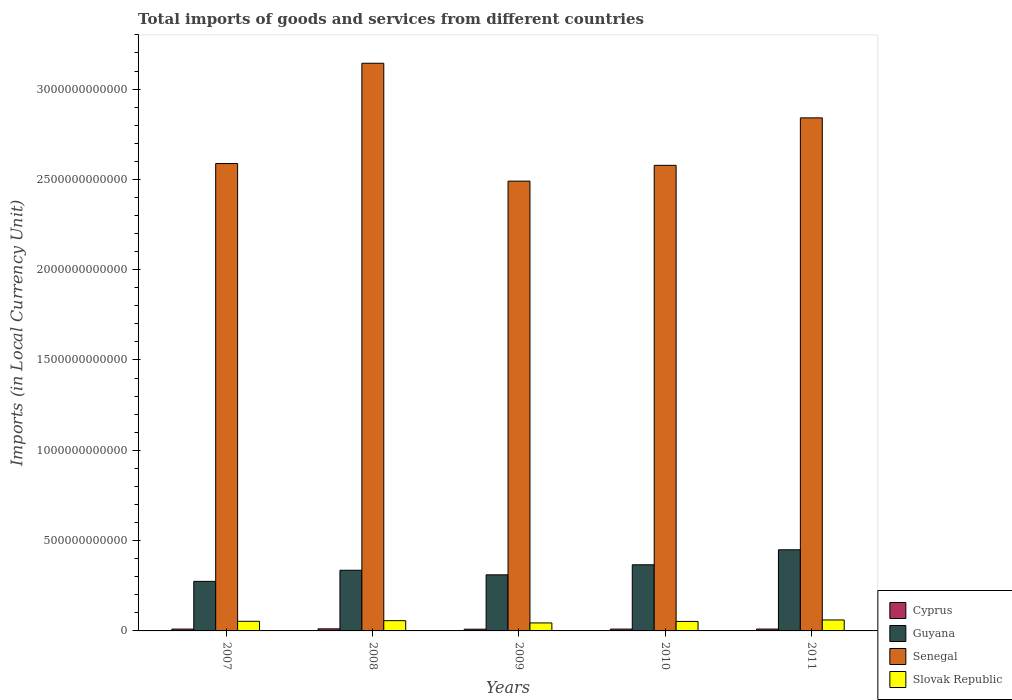How many different coloured bars are there?
Your response must be concise. 4. Are the number of bars on each tick of the X-axis equal?
Provide a succinct answer. Yes. What is the Amount of goods and services imports in Slovak Republic in 2009?
Make the answer very short. 4.42e+1. Across all years, what is the maximum Amount of goods and services imports in Guyana?
Give a very brief answer. 4.49e+11. Across all years, what is the minimum Amount of goods and services imports in Guyana?
Offer a terse response. 2.74e+11. What is the total Amount of goods and services imports in Senegal in the graph?
Your answer should be compact. 1.36e+13. What is the difference between the Amount of goods and services imports in Slovak Republic in 2008 and that in 2011?
Offer a very short reply. -3.95e+09. What is the difference between the Amount of goods and services imports in Guyana in 2011 and the Amount of goods and services imports in Cyprus in 2008?
Offer a terse response. 4.38e+11. What is the average Amount of goods and services imports in Slovak Republic per year?
Provide a short and direct response. 5.35e+1. In the year 2007, what is the difference between the Amount of goods and services imports in Senegal and Amount of goods and services imports in Slovak Republic?
Offer a terse response. 2.53e+12. What is the ratio of the Amount of goods and services imports in Senegal in 2007 to that in 2010?
Make the answer very short. 1. What is the difference between the highest and the second highest Amount of goods and services imports in Slovak Republic?
Your answer should be compact. 3.95e+09. What is the difference between the highest and the lowest Amount of goods and services imports in Slovak Republic?
Your answer should be very brief. 1.65e+1. Is it the case that in every year, the sum of the Amount of goods and services imports in Slovak Republic and Amount of goods and services imports in Cyprus is greater than the sum of Amount of goods and services imports in Guyana and Amount of goods and services imports in Senegal?
Keep it short and to the point. No. What does the 4th bar from the left in 2007 represents?
Provide a short and direct response. Slovak Republic. What does the 3rd bar from the right in 2011 represents?
Make the answer very short. Guyana. How many bars are there?
Provide a short and direct response. 20. Are all the bars in the graph horizontal?
Give a very brief answer. No. What is the difference between two consecutive major ticks on the Y-axis?
Provide a succinct answer. 5.00e+11. Are the values on the major ticks of Y-axis written in scientific E-notation?
Make the answer very short. No. Does the graph contain any zero values?
Make the answer very short. No. Where does the legend appear in the graph?
Offer a terse response. Bottom right. How many legend labels are there?
Your answer should be compact. 4. How are the legend labels stacked?
Give a very brief answer. Vertical. What is the title of the graph?
Your answer should be very brief. Total imports of goods and services from different countries. Does "Argentina" appear as one of the legend labels in the graph?
Ensure brevity in your answer.  No. What is the label or title of the X-axis?
Provide a short and direct response. Years. What is the label or title of the Y-axis?
Give a very brief answer. Imports (in Local Currency Unit). What is the Imports (in Local Currency Unit) of Cyprus in 2007?
Keep it short and to the point. 1.02e+1. What is the Imports (in Local Currency Unit) in Guyana in 2007?
Ensure brevity in your answer.  2.74e+11. What is the Imports (in Local Currency Unit) in Senegal in 2007?
Ensure brevity in your answer.  2.59e+12. What is the Imports (in Local Currency Unit) of Slovak Republic in 2007?
Offer a terse response. 5.32e+1. What is the Imports (in Local Currency Unit) of Cyprus in 2008?
Your answer should be very brief. 1.14e+1. What is the Imports (in Local Currency Unit) of Guyana in 2008?
Offer a terse response. 3.36e+11. What is the Imports (in Local Currency Unit) of Senegal in 2008?
Keep it short and to the point. 3.14e+12. What is the Imports (in Local Currency Unit) of Slovak Republic in 2008?
Keep it short and to the point. 5.68e+1. What is the Imports (in Local Currency Unit) of Cyprus in 2009?
Provide a short and direct response. 9.55e+09. What is the Imports (in Local Currency Unit) of Guyana in 2009?
Make the answer very short. 3.11e+11. What is the Imports (in Local Currency Unit) in Senegal in 2009?
Your answer should be compact. 2.49e+12. What is the Imports (in Local Currency Unit) of Slovak Republic in 2009?
Your answer should be compact. 4.42e+1. What is the Imports (in Local Currency Unit) in Cyprus in 2010?
Provide a succinct answer. 1.02e+1. What is the Imports (in Local Currency Unit) in Guyana in 2010?
Your answer should be very brief. 3.66e+11. What is the Imports (in Local Currency Unit) of Senegal in 2010?
Ensure brevity in your answer.  2.58e+12. What is the Imports (in Local Currency Unit) of Slovak Republic in 2010?
Keep it short and to the point. 5.26e+1. What is the Imports (in Local Currency Unit) of Cyprus in 2011?
Ensure brevity in your answer.  1.03e+1. What is the Imports (in Local Currency Unit) in Guyana in 2011?
Make the answer very short. 4.49e+11. What is the Imports (in Local Currency Unit) of Senegal in 2011?
Offer a very short reply. 2.84e+12. What is the Imports (in Local Currency Unit) of Slovak Republic in 2011?
Ensure brevity in your answer.  6.07e+1. Across all years, what is the maximum Imports (in Local Currency Unit) in Cyprus?
Your answer should be very brief. 1.14e+1. Across all years, what is the maximum Imports (in Local Currency Unit) of Guyana?
Keep it short and to the point. 4.49e+11. Across all years, what is the maximum Imports (in Local Currency Unit) in Senegal?
Provide a short and direct response. 3.14e+12. Across all years, what is the maximum Imports (in Local Currency Unit) of Slovak Republic?
Your response must be concise. 6.07e+1. Across all years, what is the minimum Imports (in Local Currency Unit) of Cyprus?
Provide a succinct answer. 9.55e+09. Across all years, what is the minimum Imports (in Local Currency Unit) in Guyana?
Offer a terse response. 2.74e+11. Across all years, what is the minimum Imports (in Local Currency Unit) of Senegal?
Offer a terse response. 2.49e+12. Across all years, what is the minimum Imports (in Local Currency Unit) in Slovak Republic?
Your answer should be compact. 4.42e+1. What is the total Imports (in Local Currency Unit) in Cyprus in the graph?
Offer a terse response. 5.16e+1. What is the total Imports (in Local Currency Unit) in Guyana in the graph?
Make the answer very short. 1.74e+12. What is the total Imports (in Local Currency Unit) in Senegal in the graph?
Keep it short and to the point. 1.36e+13. What is the total Imports (in Local Currency Unit) in Slovak Republic in the graph?
Give a very brief answer. 2.67e+11. What is the difference between the Imports (in Local Currency Unit) in Cyprus in 2007 and that in 2008?
Offer a terse response. -1.28e+09. What is the difference between the Imports (in Local Currency Unit) of Guyana in 2007 and that in 2008?
Provide a short and direct response. -6.15e+1. What is the difference between the Imports (in Local Currency Unit) of Senegal in 2007 and that in 2008?
Ensure brevity in your answer.  -5.55e+11. What is the difference between the Imports (in Local Currency Unit) of Slovak Republic in 2007 and that in 2008?
Ensure brevity in your answer.  -3.55e+09. What is the difference between the Imports (in Local Currency Unit) of Cyprus in 2007 and that in 2009?
Your answer should be compact. 6.09e+08. What is the difference between the Imports (in Local Currency Unit) of Guyana in 2007 and that in 2009?
Give a very brief answer. -3.62e+1. What is the difference between the Imports (in Local Currency Unit) of Senegal in 2007 and that in 2009?
Provide a short and direct response. 9.74e+1. What is the difference between the Imports (in Local Currency Unit) of Slovak Republic in 2007 and that in 2009?
Offer a very short reply. 8.98e+09. What is the difference between the Imports (in Local Currency Unit) in Cyprus in 2007 and that in 2010?
Provide a short and direct response. 1.95e+06. What is the difference between the Imports (in Local Currency Unit) in Guyana in 2007 and that in 2010?
Your answer should be compact. -9.18e+1. What is the difference between the Imports (in Local Currency Unit) in Senegal in 2007 and that in 2010?
Your response must be concise. 9.89e+09. What is the difference between the Imports (in Local Currency Unit) of Slovak Republic in 2007 and that in 2010?
Your answer should be very brief. 6.47e+08. What is the difference between the Imports (in Local Currency Unit) in Cyprus in 2007 and that in 2011?
Offer a very short reply. -1.59e+08. What is the difference between the Imports (in Local Currency Unit) of Guyana in 2007 and that in 2011?
Your answer should be very brief. -1.75e+11. What is the difference between the Imports (in Local Currency Unit) in Senegal in 2007 and that in 2011?
Make the answer very short. -2.53e+11. What is the difference between the Imports (in Local Currency Unit) of Slovak Republic in 2007 and that in 2011?
Your answer should be compact. -7.50e+09. What is the difference between the Imports (in Local Currency Unit) of Cyprus in 2008 and that in 2009?
Your answer should be compact. 1.89e+09. What is the difference between the Imports (in Local Currency Unit) of Guyana in 2008 and that in 2009?
Your response must be concise. 2.53e+1. What is the difference between the Imports (in Local Currency Unit) of Senegal in 2008 and that in 2009?
Your response must be concise. 6.53e+11. What is the difference between the Imports (in Local Currency Unit) in Slovak Republic in 2008 and that in 2009?
Your response must be concise. 1.25e+1. What is the difference between the Imports (in Local Currency Unit) of Cyprus in 2008 and that in 2010?
Make the answer very short. 1.28e+09. What is the difference between the Imports (in Local Currency Unit) in Guyana in 2008 and that in 2010?
Make the answer very short. -3.03e+1. What is the difference between the Imports (in Local Currency Unit) of Senegal in 2008 and that in 2010?
Your answer should be very brief. 5.65e+11. What is the difference between the Imports (in Local Currency Unit) of Slovak Republic in 2008 and that in 2010?
Your response must be concise. 4.20e+09. What is the difference between the Imports (in Local Currency Unit) of Cyprus in 2008 and that in 2011?
Offer a terse response. 1.12e+09. What is the difference between the Imports (in Local Currency Unit) of Guyana in 2008 and that in 2011?
Give a very brief answer. -1.13e+11. What is the difference between the Imports (in Local Currency Unit) of Senegal in 2008 and that in 2011?
Offer a very short reply. 3.02e+11. What is the difference between the Imports (in Local Currency Unit) in Slovak Republic in 2008 and that in 2011?
Your answer should be compact. -3.95e+09. What is the difference between the Imports (in Local Currency Unit) in Cyprus in 2009 and that in 2010?
Offer a terse response. -6.08e+08. What is the difference between the Imports (in Local Currency Unit) in Guyana in 2009 and that in 2010?
Your answer should be very brief. -5.56e+1. What is the difference between the Imports (in Local Currency Unit) in Senegal in 2009 and that in 2010?
Ensure brevity in your answer.  -8.75e+1. What is the difference between the Imports (in Local Currency Unit) in Slovak Republic in 2009 and that in 2010?
Give a very brief answer. -8.33e+09. What is the difference between the Imports (in Local Currency Unit) of Cyprus in 2009 and that in 2011?
Ensure brevity in your answer.  -7.69e+08. What is the difference between the Imports (in Local Currency Unit) of Guyana in 2009 and that in 2011?
Your response must be concise. -1.39e+11. What is the difference between the Imports (in Local Currency Unit) of Senegal in 2009 and that in 2011?
Offer a very short reply. -3.50e+11. What is the difference between the Imports (in Local Currency Unit) of Slovak Republic in 2009 and that in 2011?
Your answer should be compact. -1.65e+1. What is the difference between the Imports (in Local Currency Unit) of Cyprus in 2010 and that in 2011?
Your response must be concise. -1.61e+08. What is the difference between the Imports (in Local Currency Unit) of Guyana in 2010 and that in 2011?
Your answer should be compact. -8.30e+1. What is the difference between the Imports (in Local Currency Unit) of Senegal in 2010 and that in 2011?
Provide a succinct answer. -2.63e+11. What is the difference between the Imports (in Local Currency Unit) of Slovak Republic in 2010 and that in 2011?
Keep it short and to the point. -8.14e+09. What is the difference between the Imports (in Local Currency Unit) in Cyprus in 2007 and the Imports (in Local Currency Unit) in Guyana in 2008?
Make the answer very short. -3.26e+11. What is the difference between the Imports (in Local Currency Unit) of Cyprus in 2007 and the Imports (in Local Currency Unit) of Senegal in 2008?
Your answer should be compact. -3.13e+12. What is the difference between the Imports (in Local Currency Unit) in Cyprus in 2007 and the Imports (in Local Currency Unit) in Slovak Republic in 2008?
Keep it short and to the point. -4.66e+1. What is the difference between the Imports (in Local Currency Unit) in Guyana in 2007 and the Imports (in Local Currency Unit) in Senegal in 2008?
Offer a terse response. -2.87e+12. What is the difference between the Imports (in Local Currency Unit) of Guyana in 2007 and the Imports (in Local Currency Unit) of Slovak Republic in 2008?
Your response must be concise. 2.18e+11. What is the difference between the Imports (in Local Currency Unit) of Senegal in 2007 and the Imports (in Local Currency Unit) of Slovak Republic in 2008?
Give a very brief answer. 2.53e+12. What is the difference between the Imports (in Local Currency Unit) of Cyprus in 2007 and the Imports (in Local Currency Unit) of Guyana in 2009?
Your answer should be compact. -3.00e+11. What is the difference between the Imports (in Local Currency Unit) of Cyprus in 2007 and the Imports (in Local Currency Unit) of Senegal in 2009?
Provide a short and direct response. -2.48e+12. What is the difference between the Imports (in Local Currency Unit) in Cyprus in 2007 and the Imports (in Local Currency Unit) in Slovak Republic in 2009?
Offer a very short reply. -3.41e+1. What is the difference between the Imports (in Local Currency Unit) in Guyana in 2007 and the Imports (in Local Currency Unit) in Senegal in 2009?
Keep it short and to the point. -2.22e+12. What is the difference between the Imports (in Local Currency Unit) in Guyana in 2007 and the Imports (in Local Currency Unit) in Slovak Republic in 2009?
Offer a terse response. 2.30e+11. What is the difference between the Imports (in Local Currency Unit) in Senegal in 2007 and the Imports (in Local Currency Unit) in Slovak Republic in 2009?
Your answer should be very brief. 2.54e+12. What is the difference between the Imports (in Local Currency Unit) of Cyprus in 2007 and the Imports (in Local Currency Unit) of Guyana in 2010?
Offer a terse response. -3.56e+11. What is the difference between the Imports (in Local Currency Unit) of Cyprus in 2007 and the Imports (in Local Currency Unit) of Senegal in 2010?
Provide a succinct answer. -2.57e+12. What is the difference between the Imports (in Local Currency Unit) of Cyprus in 2007 and the Imports (in Local Currency Unit) of Slovak Republic in 2010?
Your answer should be very brief. -4.24e+1. What is the difference between the Imports (in Local Currency Unit) in Guyana in 2007 and the Imports (in Local Currency Unit) in Senegal in 2010?
Your answer should be compact. -2.30e+12. What is the difference between the Imports (in Local Currency Unit) in Guyana in 2007 and the Imports (in Local Currency Unit) in Slovak Republic in 2010?
Offer a very short reply. 2.22e+11. What is the difference between the Imports (in Local Currency Unit) of Senegal in 2007 and the Imports (in Local Currency Unit) of Slovak Republic in 2010?
Make the answer very short. 2.54e+12. What is the difference between the Imports (in Local Currency Unit) in Cyprus in 2007 and the Imports (in Local Currency Unit) in Guyana in 2011?
Offer a very short reply. -4.39e+11. What is the difference between the Imports (in Local Currency Unit) in Cyprus in 2007 and the Imports (in Local Currency Unit) in Senegal in 2011?
Keep it short and to the point. -2.83e+12. What is the difference between the Imports (in Local Currency Unit) in Cyprus in 2007 and the Imports (in Local Currency Unit) in Slovak Republic in 2011?
Your answer should be compact. -5.06e+1. What is the difference between the Imports (in Local Currency Unit) in Guyana in 2007 and the Imports (in Local Currency Unit) in Senegal in 2011?
Provide a succinct answer. -2.57e+12. What is the difference between the Imports (in Local Currency Unit) in Guyana in 2007 and the Imports (in Local Currency Unit) in Slovak Republic in 2011?
Your answer should be compact. 2.14e+11. What is the difference between the Imports (in Local Currency Unit) in Senegal in 2007 and the Imports (in Local Currency Unit) in Slovak Republic in 2011?
Provide a succinct answer. 2.53e+12. What is the difference between the Imports (in Local Currency Unit) in Cyprus in 2008 and the Imports (in Local Currency Unit) in Guyana in 2009?
Your answer should be compact. -2.99e+11. What is the difference between the Imports (in Local Currency Unit) of Cyprus in 2008 and the Imports (in Local Currency Unit) of Senegal in 2009?
Make the answer very short. -2.48e+12. What is the difference between the Imports (in Local Currency Unit) of Cyprus in 2008 and the Imports (in Local Currency Unit) of Slovak Republic in 2009?
Offer a terse response. -3.28e+1. What is the difference between the Imports (in Local Currency Unit) of Guyana in 2008 and the Imports (in Local Currency Unit) of Senegal in 2009?
Provide a succinct answer. -2.15e+12. What is the difference between the Imports (in Local Currency Unit) of Guyana in 2008 and the Imports (in Local Currency Unit) of Slovak Republic in 2009?
Your answer should be very brief. 2.92e+11. What is the difference between the Imports (in Local Currency Unit) of Senegal in 2008 and the Imports (in Local Currency Unit) of Slovak Republic in 2009?
Give a very brief answer. 3.10e+12. What is the difference between the Imports (in Local Currency Unit) in Cyprus in 2008 and the Imports (in Local Currency Unit) in Guyana in 2010?
Offer a very short reply. -3.55e+11. What is the difference between the Imports (in Local Currency Unit) in Cyprus in 2008 and the Imports (in Local Currency Unit) in Senegal in 2010?
Give a very brief answer. -2.57e+12. What is the difference between the Imports (in Local Currency Unit) of Cyprus in 2008 and the Imports (in Local Currency Unit) of Slovak Republic in 2010?
Give a very brief answer. -4.11e+1. What is the difference between the Imports (in Local Currency Unit) of Guyana in 2008 and the Imports (in Local Currency Unit) of Senegal in 2010?
Ensure brevity in your answer.  -2.24e+12. What is the difference between the Imports (in Local Currency Unit) of Guyana in 2008 and the Imports (in Local Currency Unit) of Slovak Republic in 2010?
Offer a terse response. 2.83e+11. What is the difference between the Imports (in Local Currency Unit) of Senegal in 2008 and the Imports (in Local Currency Unit) of Slovak Republic in 2010?
Keep it short and to the point. 3.09e+12. What is the difference between the Imports (in Local Currency Unit) of Cyprus in 2008 and the Imports (in Local Currency Unit) of Guyana in 2011?
Give a very brief answer. -4.38e+11. What is the difference between the Imports (in Local Currency Unit) in Cyprus in 2008 and the Imports (in Local Currency Unit) in Senegal in 2011?
Provide a succinct answer. -2.83e+12. What is the difference between the Imports (in Local Currency Unit) in Cyprus in 2008 and the Imports (in Local Currency Unit) in Slovak Republic in 2011?
Provide a short and direct response. -4.93e+1. What is the difference between the Imports (in Local Currency Unit) in Guyana in 2008 and the Imports (in Local Currency Unit) in Senegal in 2011?
Provide a short and direct response. -2.50e+12. What is the difference between the Imports (in Local Currency Unit) of Guyana in 2008 and the Imports (in Local Currency Unit) of Slovak Republic in 2011?
Offer a terse response. 2.75e+11. What is the difference between the Imports (in Local Currency Unit) in Senegal in 2008 and the Imports (in Local Currency Unit) in Slovak Republic in 2011?
Offer a terse response. 3.08e+12. What is the difference between the Imports (in Local Currency Unit) in Cyprus in 2009 and the Imports (in Local Currency Unit) in Guyana in 2010?
Your answer should be very brief. -3.57e+11. What is the difference between the Imports (in Local Currency Unit) of Cyprus in 2009 and the Imports (in Local Currency Unit) of Senegal in 2010?
Your answer should be compact. -2.57e+12. What is the difference between the Imports (in Local Currency Unit) of Cyprus in 2009 and the Imports (in Local Currency Unit) of Slovak Republic in 2010?
Offer a terse response. -4.30e+1. What is the difference between the Imports (in Local Currency Unit) in Guyana in 2009 and the Imports (in Local Currency Unit) in Senegal in 2010?
Provide a succinct answer. -2.27e+12. What is the difference between the Imports (in Local Currency Unit) of Guyana in 2009 and the Imports (in Local Currency Unit) of Slovak Republic in 2010?
Provide a succinct answer. 2.58e+11. What is the difference between the Imports (in Local Currency Unit) in Senegal in 2009 and the Imports (in Local Currency Unit) in Slovak Republic in 2010?
Your answer should be compact. 2.44e+12. What is the difference between the Imports (in Local Currency Unit) of Cyprus in 2009 and the Imports (in Local Currency Unit) of Guyana in 2011?
Provide a succinct answer. -4.40e+11. What is the difference between the Imports (in Local Currency Unit) in Cyprus in 2009 and the Imports (in Local Currency Unit) in Senegal in 2011?
Provide a short and direct response. -2.83e+12. What is the difference between the Imports (in Local Currency Unit) of Cyprus in 2009 and the Imports (in Local Currency Unit) of Slovak Republic in 2011?
Your answer should be compact. -5.12e+1. What is the difference between the Imports (in Local Currency Unit) in Guyana in 2009 and the Imports (in Local Currency Unit) in Senegal in 2011?
Ensure brevity in your answer.  -2.53e+12. What is the difference between the Imports (in Local Currency Unit) of Guyana in 2009 and the Imports (in Local Currency Unit) of Slovak Republic in 2011?
Your answer should be very brief. 2.50e+11. What is the difference between the Imports (in Local Currency Unit) of Senegal in 2009 and the Imports (in Local Currency Unit) of Slovak Republic in 2011?
Offer a very short reply. 2.43e+12. What is the difference between the Imports (in Local Currency Unit) in Cyprus in 2010 and the Imports (in Local Currency Unit) in Guyana in 2011?
Provide a short and direct response. -4.39e+11. What is the difference between the Imports (in Local Currency Unit) of Cyprus in 2010 and the Imports (in Local Currency Unit) of Senegal in 2011?
Offer a terse response. -2.83e+12. What is the difference between the Imports (in Local Currency Unit) of Cyprus in 2010 and the Imports (in Local Currency Unit) of Slovak Republic in 2011?
Ensure brevity in your answer.  -5.06e+1. What is the difference between the Imports (in Local Currency Unit) in Guyana in 2010 and the Imports (in Local Currency Unit) in Senegal in 2011?
Provide a succinct answer. -2.47e+12. What is the difference between the Imports (in Local Currency Unit) of Guyana in 2010 and the Imports (in Local Currency Unit) of Slovak Republic in 2011?
Provide a short and direct response. 3.05e+11. What is the difference between the Imports (in Local Currency Unit) of Senegal in 2010 and the Imports (in Local Currency Unit) of Slovak Republic in 2011?
Offer a terse response. 2.52e+12. What is the average Imports (in Local Currency Unit) in Cyprus per year?
Keep it short and to the point. 1.03e+1. What is the average Imports (in Local Currency Unit) in Guyana per year?
Give a very brief answer. 3.47e+11. What is the average Imports (in Local Currency Unit) of Senegal per year?
Offer a terse response. 2.73e+12. What is the average Imports (in Local Currency Unit) in Slovak Republic per year?
Your answer should be compact. 5.35e+1. In the year 2007, what is the difference between the Imports (in Local Currency Unit) in Cyprus and Imports (in Local Currency Unit) in Guyana?
Your answer should be compact. -2.64e+11. In the year 2007, what is the difference between the Imports (in Local Currency Unit) in Cyprus and Imports (in Local Currency Unit) in Senegal?
Ensure brevity in your answer.  -2.58e+12. In the year 2007, what is the difference between the Imports (in Local Currency Unit) in Cyprus and Imports (in Local Currency Unit) in Slovak Republic?
Your answer should be very brief. -4.31e+1. In the year 2007, what is the difference between the Imports (in Local Currency Unit) in Guyana and Imports (in Local Currency Unit) in Senegal?
Your answer should be very brief. -2.31e+12. In the year 2007, what is the difference between the Imports (in Local Currency Unit) in Guyana and Imports (in Local Currency Unit) in Slovak Republic?
Your answer should be very brief. 2.21e+11. In the year 2007, what is the difference between the Imports (in Local Currency Unit) in Senegal and Imports (in Local Currency Unit) in Slovak Republic?
Your answer should be compact. 2.53e+12. In the year 2008, what is the difference between the Imports (in Local Currency Unit) in Cyprus and Imports (in Local Currency Unit) in Guyana?
Offer a terse response. -3.24e+11. In the year 2008, what is the difference between the Imports (in Local Currency Unit) of Cyprus and Imports (in Local Currency Unit) of Senegal?
Provide a short and direct response. -3.13e+12. In the year 2008, what is the difference between the Imports (in Local Currency Unit) of Cyprus and Imports (in Local Currency Unit) of Slovak Republic?
Give a very brief answer. -4.53e+1. In the year 2008, what is the difference between the Imports (in Local Currency Unit) in Guyana and Imports (in Local Currency Unit) in Senegal?
Provide a short and direct response. -2.81e+12. In the year 2008, what is the difference between the Imports (in Local Currency Unit) in Guyana and Imports (in Local Currency Unit) in Slovak Republic?
Your answer should be very brief. 2.79e+11. In the year 2008, what is the difference between the Imports (in Local Currency Unit) of Senegal and Imports (in Local Currency Unit) of Slovak Republic?
Your answer should be very brief. 3.09e+12. In the year 2009, what is the difference between the Imports (in Local Currency Unit) of Cyprus and Imports (in Local Currency Unit) of Guyana?
Offer a terse response. -3.01e+11. In the year 2009, what is the difference between the Imports (in Local Currency Unit) of Cyprus and Imports (in Local Currency Unit) of Senegal?
Offer a very short reply. -2.48e+12. In the year 2009, what is the difference between the Imports (in Local Currency Unit) of Cyprus and Imports (in Local Currency Unit) of Slovak Republic?
Make the answer very short. -3.47e+1. In the year 2009, what is the difference between the Imports (in Local Currency Unit) of Guyana and Imports (in Local Currency Unit) of Senegal?
Your answer should be compact. -2.18e+12. In the year 2009, what is the difference between the Imports (in Local Currency Unit) of Guyana and Imports (in Local Currency Unit) of Slovak Republic?
Give a very brief answer. 2.66e+11. In the year 2009, what is the difference between the Imports (in Local Currency Unit) in Senegal and Imports (in Local Currency Unit) in Slovak Republic?
Keep it short and to the point. 2.45e+12. In the year 2010, what is the difference between the Imports (in Local Currency Unit) of Cyprus and Imports (in Local Currency Unit) of Guyana?
Ensure brevity in your answer.  -3.56e+11. In the year 2010, what is the difference between the Imports (in Local Currency Unit) of Cyprus and Imports (in Local Currency Unit) of Senegal?
Your answer should be compact. -2.57e+12. In the year 2010, what is the difference between the Imports (in Local Currency Unit) of Cyprus and Imports (in Local Currency Unit) of Slovak Republic?
Ensure brevity in your answer.  -4.24e+1. In the year 2010, what is the difference between the Imports (in Local Currency Unit) of Guyana and Imports (in Local Currency Unit) of Senegal?
Provide a short and direct response. -2.21e+12. In the year 2010, what is the difference between the Imports (in Local Currency Unit) in Guyana and Imports (in Local Currency Unit) in Slovak Republic?
Offer a terse response. 3.14e+11. In the year 2010, what is the difference between the Imports (in Local Currency Unit) of Senegal and Imports (in Local Currency Unit) of Slovak Republic?
Your answer should be very brief. 2.53e+12. In the year 2011, what is the difference between the Imports (in Local Currency Unit) of Cyprus and Imports (in Local Currency Unit) of Guyana?
Provide a succinct answer. -4.39e+11. In the year 2011, what is the difference between the Imports (in Local Currency Unit) in Cyprus and Imports (in Local Currency Unit) in Senegal?
Your response must be concise. -2.83e+12. In the year 2011, what is the difference between the Imports (in Local Currency Unit) of Cyprus and Imports (in Local Currency Unit) of Slovak Republic?
Offer a terse response. -5.04e+1. In the year 2011, what is the difference between the Imports (in Local Currency Unit) of Guyana and Imports (in Local Currency Unit) of Senegal?
Keep it short and to the point. -2.39e+12. In the year 2011, what is the difference between the Imports (in Local Currency Unit) of Guyana and Imports (in Local Currency Unit) of Slovak Republic?
Offer a very short reply. 3.88e+11. In the year 2011, what is the difference between the Imports (in Local Currency Unit) in Senegal and Imports (in Local Currency Unit) in Slovak Republic?
Keep it short and to the point. 2.78e+12. What is the ratio of the Imports (in Local Currency Unit) in Cyprus in 2007 to that in 2008?
Your response must be concise. 0.89. What is the ratio of the Imports (in Local Currency Unit) of Guyana in 2007 to that in 2008?
Ensure brevity in your answer.  0.82. What is the ratio of the Imports (in Local Currency Unit) in Senegal in 2007 to that in 2008?
Your answer should be very brief. 0.82. What is the ratio of the Imports (in Local Currency Unit) of Slovak Republic in 2007 to that in 2008?
Offer a very short reply. 0.94. What is the ratio of the Imports (in Local Currency Unit) in Cyprus in 2007 to that in 2009?
Ensure brevity in your answer.  1.06. What is the ratio of the Imports (in Local Currency Unit) of Guyana in 2007 to that in 2009?
Keep it short and to the point. 0.88. What is the ratio of the Imports (in Local Currency Unit) in Senegal in 2007 to that in 2009?
Make the answer very short. 1.04. What is the ratio of the Imports (in Local Currency Unit) in Slovak Republic in 2007 to that in 2009?
Your answer should be compact. 1.2. What is the ratio of the Imports (in Local Currency Unit) in Guyana in 2007 to that in 2010?
Offer a terse response. 0.75. What is the ratio of the Imports (in Local Currency Unit) in Senegal in 2007 to that in 2010?
Offer a very short reply. 1. What is the ratio of the Imports (in Local Currency Unit) in Slovak Republic in 2007 to that in 2010?
Provide a short and direct response. 1.01. What is the ratio of the Imports (in Local Currency Unit) in Cyprus in 2007 to that in 2011?
Your answer should be compact. 0.98. What is the ratio of the Imports (in Local Currency Unit) in Guyana in 2007 to that in 2011?
Your response must be concise. 0.61. What is the ratio of the Imports (in Local Currency Unit) of Senegal in 2007 to that in 2011?
Provide a short and direct response. 0.91. What is the ratio of the Imports (in Local Currency Unit) of Slovak Republic in 2007 to that in 2011?
Keep it short and to the point. 0.88. What is the ratio of the Imports (in Local Currency Unit) of Cyprus in 2008 to that in 2009?
Keep it short and to the point. 1.2. What is the ratio of the Imports (in Local Currency Unit) in Guyana in 2008 to that in 2009?
Make the answer very short. 1.08. What is the ratio of the Imports (in Local Currency Unit) in Senegal in 2008 to that in 2009?
Provide a succinct answer. 1.26. What is the ratio of the Imports (in Local Currency Unit) of Slovak Republic in 2008 to that in 2009?
Provide a short and direct response. 1.28. What is the ratio of the Imports (in Local Currency Unit) in Cyprus in 2008 to that in 2010?
Offer a very short reply. 1.13. What is the ratio of the Imports (in Local Currency Unit) in Guyana in 2008 to that in 2010?
Offer a very short reply. 0.92. What is the ratio of the Imports (in Local Currency Unit) in Senegal in 2008 to that in 2010?
Offer a very short reply. 1.22. What is the ratio of the Imports (in Local Currency Unit) of Slovak Republic in 2008 to that in 2010?
Your answer should be very brief. 1.08. What is the ratio of the Imports (in Local Currency Unit) of Cyprus in 2008 to that in 2011?
Provide a succinct answer. 1.11. What is the ratio of the Imports (in Local Currency Unit) in Guyana in 2008 to that in 2011?
Ensure brevity in your answer.  0.75. What is the ratio of the Imports (in Local Currency Unit) of Senegal in 2008 to that in 2011?
Provide a succinct answer. 1.11. What is the ratio of the Imports (in Local Currency Unit) in Slovak Republic in 2008 to that in 2011?
Ensure brevity in your answer.  0.94. What is the ratio of the Imports (in Local Currency Unit) in Cyprus in 2009 to that in 2010?
Provide a succinct answer. 0.94. What is the ratio of the Imports (in Local Currency Unit) of Guyana in 2009 to that in 2010?
Give a very brief answer. 0.85. What is the ratio of the Imports (in Local Currency Unit) in Senegal in 2009 to that in 2010?
Your answer should be compact. 0.97. What is the ratio of the Imports (in Local Currency Unit) of Slovak Republic in 2009 to that in 2010?
Your response must be concise. 0.84. What is the ratio of the Imports (in Local Currency Unit) of Cyprus in 2009 to that in 2011?
Keep it short and to the point. 0.93. What is the ratio of the Imports (in Local Currency Unit) of Guyana in 2009 to that in 2011?
Offer a very short reply. 0.69. What is the ratio of the Imports (in Local Currency Unit) in Senegal in 2009 to that in 2011?
Offer a very short reply. 0.88. What is the ratio of the Imports (in Local Currency Unit) of Slovak Republic in 2009 to that in 2011?
Ensure brevity in your answer.  0.73. What is the ratio of the Imports (in Local Currency Unit) of Cyprus in 2010 to that in 2011?
Offer a terse response. 0.98. What is the ratio of the Imports (in Local Currency Unit) of Guyana in 2010 to that in 2011?
Your response must be concise. 0.82. What is the ratio of the Imports (in Local Currency Unit) in Senegal in 2010 to that in 2011?
Offer a very short reply. 0.91. What is the ratio of the Imports (in Local Currency Unit) of Slovak Republic in 2010 to that in 2011?
Make the answer very short. 0.87. What is the difference between the highest and the second highest Imports (in Local Currency Unit) of Cyprus?
Keep it short and to the point. 1.12e+09. What is the difference between the highest and the second highest Imports (in Local Currency Unit) of Guyana?
Your answer should be very brief. 8.30e+1. What is the difference between the highest and the second highest Imports (in Local Currency Unit) in Senegal?
Make the answer very short. 3.02e+11. What is the difference between the highest and the second highest Imports (in Local Currency Unit) in Slovak Republic?
Provide a short and direct response. 3.95e+09. What is the difference between the highest and the lowest Imports (in Local Currency Unit) of Cyprus?
Provide a succinct answer. 1.89e+09. What is the difference between the highest and the lowest Imports (in Local Currency Unit) of Guyana?
Your answer should be compact. 1.75e+11. What is the difference between the highest and the lowest Imports (in Local Currency Unit) of Senegal?
Your response must be concise. 6.53e+11. What is the difference between the highest and the lowest Imports (in Local Currency Unit) in Slovak Republic?
Provide a succinct answer. 1.65e+1. 